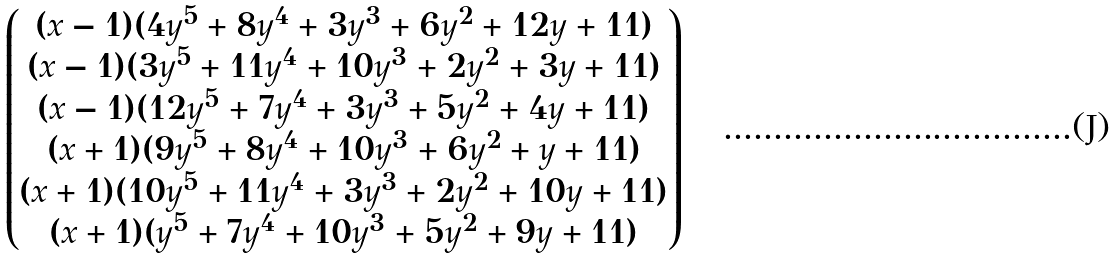<formula> <loc_0><loc_0><loc_500><loc_500>\begin{pmatrix} ( x - 1 ) ( 4 y ^ { 5 } + 8 y ^ { 4 } + 3 y ^ { 3 } + 6 y ^ { 2 } + 1 2 y + 1 1 ) \\ ( x - 1 ) ( 3 y ^ { 5 } + 1 1 y ^ { 4 } + 1 0 y ^ { 3 } + 2 y ^ { 2 } + 3 y + 1 1 ) \\ ( x - 1 ) ( 1 2 y ^ { 5 } + 7 y ^ { 4 } + 3 y ^ { 3 } + 5 y ^ { 2 } + 4 y + 1 1 ) \\ ( x + 1 ) ( 9 y ^ { 5 } + 8 y ^ { 4 } + 1 0 y ^ { 3 } + 6 y ^ { 2 } + y + 1 1 ) \\ ( x + 1 ) ( 1 0 y ^ { 5 } + 1 1 y ^ { 4 } + 3 y ^ { 3 } + 2 y ^ { 2 } + 1 0 y + 1 1 ) \\ ( x + 1 ) ( y ^ { 5 } + 7 y ^ { 4 } + 1 0 y ^ { 3 } + 5 y ^ { 2 } + 9 y + 1 1 ) \end{pmatrix}</formula> 